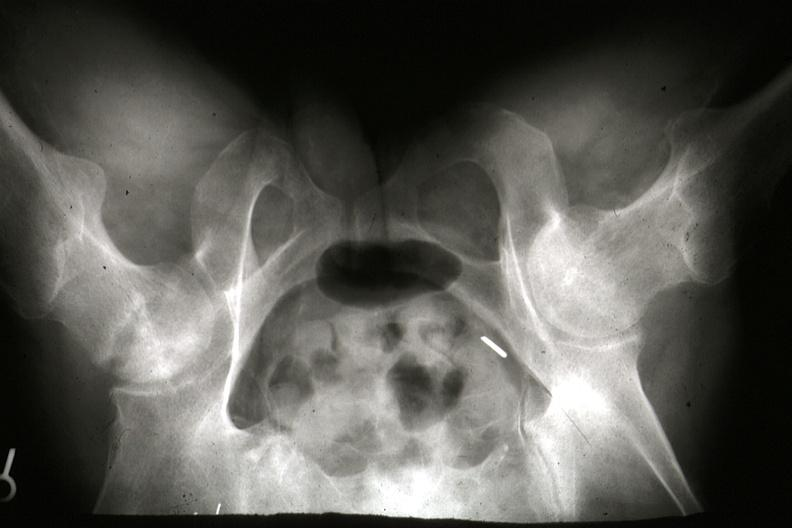how is x-ray of pelvis during life showing osteonecrosis in femoral head slides?
Answer the question using a single word or phrase. Right 